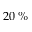<formula> <loc_0><loc_0><loc_500><loc_500>2 0 \, \%</formula> 